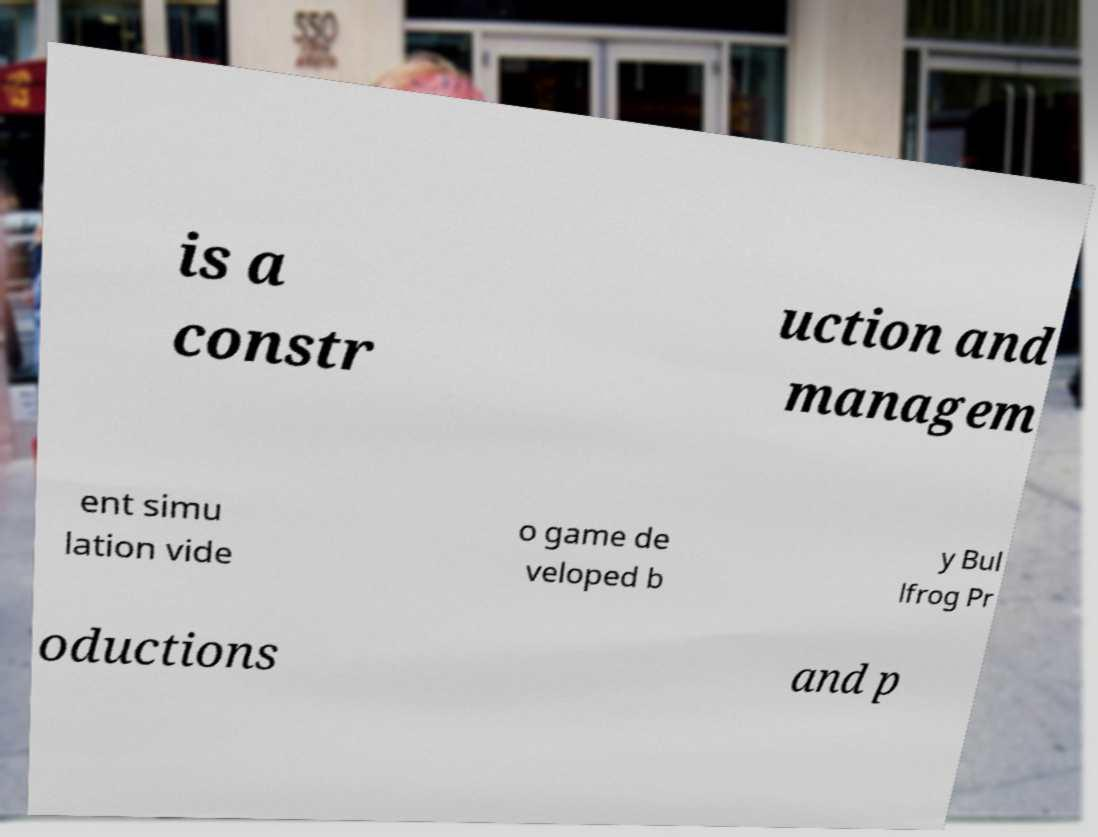I need the written content from this picture converted into text. Can you do that? is a constr uction and managem ent simu lation vide o game de veloped b y Bul lfrog Pr oductions and p 